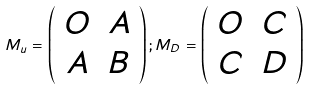<formula> <loc_0><loc_0><loc_500><loc_500>M _ { u } = \left ( \begin{array} { c c } O & A \\ A & B \end{array} \right ) ; M _ { D } = \left ( \begin{array} { c c } O & C \\ C & D \end{array} \right )</formula> 